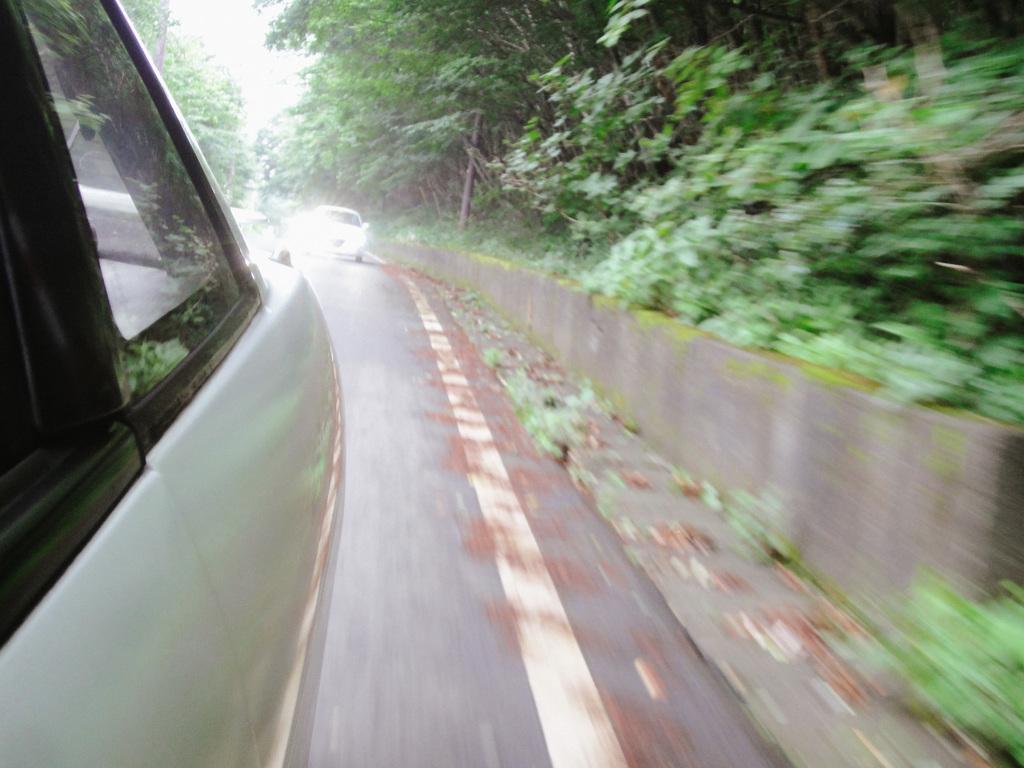Please provide a concise description of this image. In the image we can see there are vehicles on the road. Here we can see the tall, grass, plants, trees and the sky.  